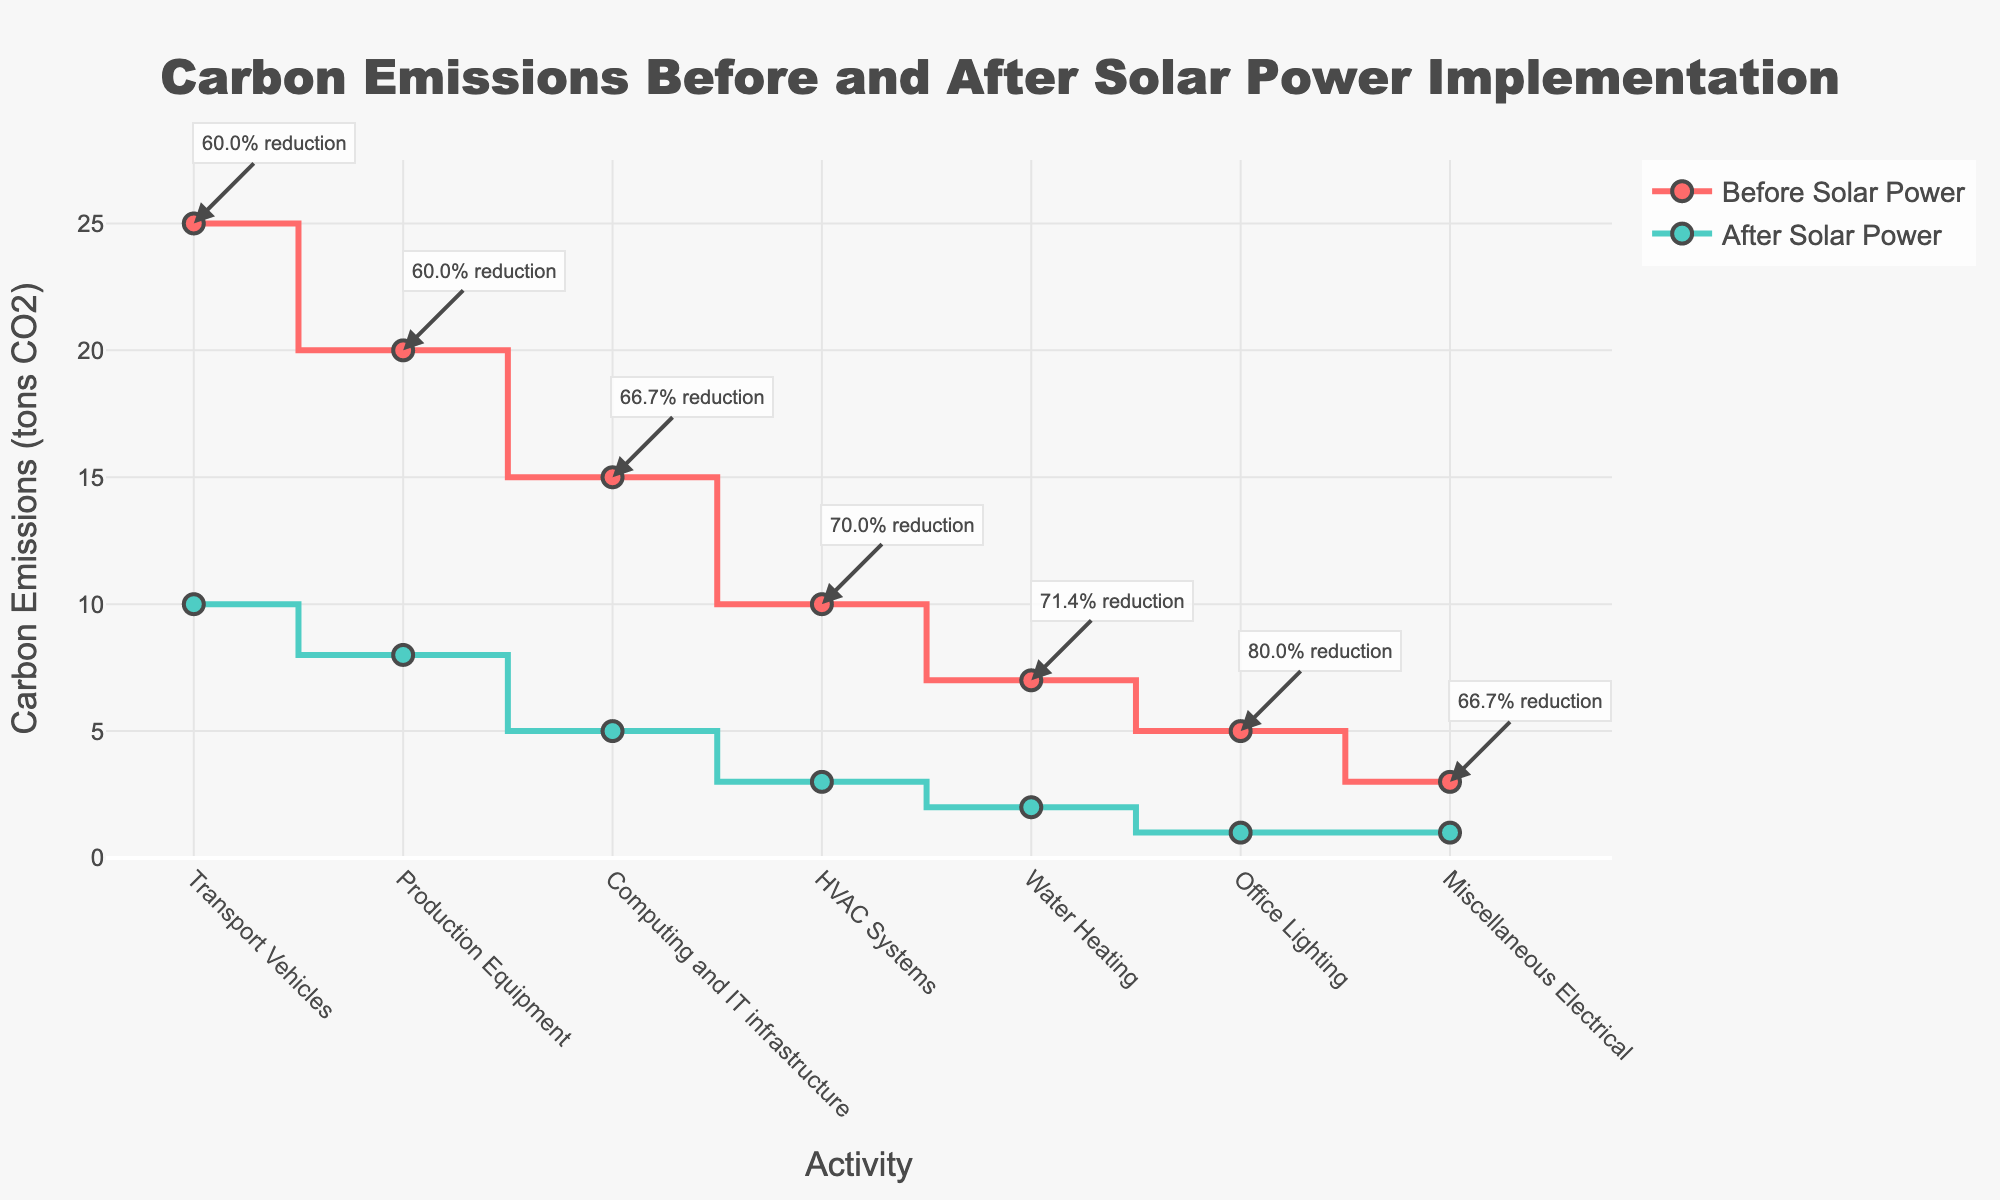How many activities are tracked in the figure? The x-axis of the figure lists all the activities tracked. Count each one to determine the total number.
Answer: 7 What activity has the highest carbon emissions before applying solar power? The plot displays the 'Before Solar Power' values for each activity. The highest value corresponds to 'Transport Vehicles'.
Answer: Transport Vehicles What percentage of reduction in carbon emissions does the 'Production Equipment' show after applying solar power? The annotation for 'Production Equipment' indicates the percentage reduction in carbon emissions.
Answer: 60.0% Which activity had the lowest carbon emissions before applying solar power? By looking at the 'Before Solar Power' series, the lowest value corresponds to 'Miscellaneous Electrical'.
Answer: Miscellaneous Electrical What is the difference in carbon emissions for 'Office Lighting' before and after applying solar power? Subtract the 'After Solar Power' value from the 'Before Solar Power' value for 'Office Lighting'.
Answer: 4.0 tons CO2 Which activity has the smallest reduction in carbon emissions in absolute terms after applying solar power? To identify the smallest absolute reduction, compare the before and after values for each activity and find the smallest difference.
Answer: Miscellaneous Electrical What is the total reduction in carbon emissions for 'HVAC Systems' after applying solar power? Calculate the difference between 'Before Solar Power' and 'After Solar Power' for 'HVAC Systems'.
Answer: 7.0 tons CO2 Which activity shows a larger percentage decrease in emissions: 'Transport Vehicles' or 'Water Heating'? Compare the percentage reductions noted in the annotations for 'Transport Vehicles' and 'Water Heating'.
Answer: Water Heating How much CO2 is saved annually by applying solar power to computing and IT infrastructure? Subtract the 'After Solar Power' value from the 'Before Solar Power' value for the 'Computing and IT infrastructure' category.
Answer: 10.0 tons CO2 What activity shows the smallest percentage reduction in emissions after applying solar power? Examine the annotations for percentage reductions. The smallest percentage reduction is associated with 'Miscellaneous Electrical'.
Answer: Miscellaneous Electrical 